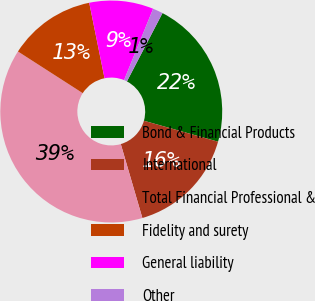Convert chart. <chart><loc_0><loc_0><loc_500><loc_500><pie_chart><fcel>Bond & Financial Products<fcel>International<fcel>Total Financial Professional &<fcel>Fidelity and surety<fcel>General liability<fcel>Other<nl><fcel>21.75%<fcel>16.09%<fcel>38.62%<fcel>12.72%<fcel>9.34%<fcel>1.48%<nl></chart> 